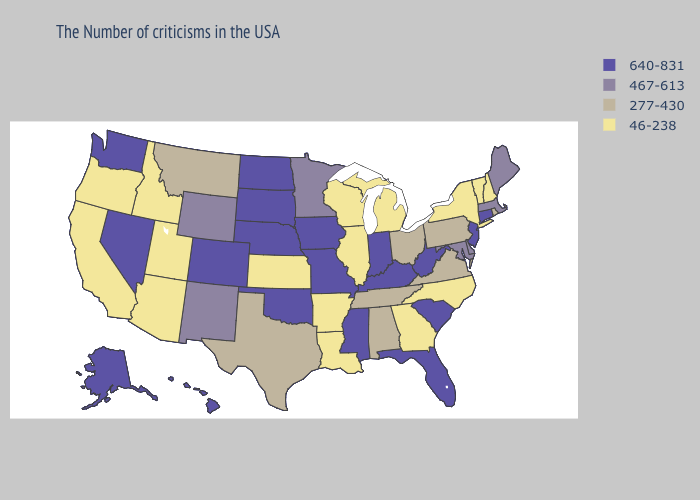Name the states that have a value in the range 467-613?
Quick response, please. Maine, Massachusetts, Delaware, Maryland, Minnesota, Wyoming, New Mexico. Does Utah have a lower value than New Mexico?
Short answer required. Yes. What is the highest value in the MidWest ?
Write a very short answer. 640-831. Which states have the lowest value in the South?
Quick response, please. North Carolina, Georgia, Louisiana, Arkansas. What is the value of California?
Write a very short answer. 46-238. What is the highest value in the USA?
Concise answer only. 640-831. Name the states that have a value in the range 640-831?
Keep it brief. Connecticut, New Jersey, South Carolina, West Virginia, Florida, Kentucky, Indiana, Mississippi, Missouri, Iowa, Nebraska, Oklahoma, South Dakota, North Dakota, Colorado, Nevada, Washington, Alaska, Hawaii. Does the first symbol in the legend represent the smallest category?
Be succinct. No. What is the value of Maine?
Give a very brief answer. 467-613. Which states hav the highest value in the Northeast?
Short answer required. Connecticut, New Jersey. What is the lowest value in states that border Kansas?
Concise answer only. 640-831. What is the lowest value in states that border Texas?
Answer briefly. 46-238. What is the highest value in the South ?
Quick response, please. 640-831. Name the states that have a value in the range 640-831?
Concise answer only. Connecticut, New Jersey, South Carolina, West Virginia, Florida, Kentucky, Indiana, Mississippi, Missouri, Iowa, Nebraska, Oklahoma, South Dakota, North Dakota, Colorado, Nevada, Washington, Alaska, Hawaii. Among the states that border Massachusetts , does Connecticut have the highest value?
Give a very brief answer. Yes. 